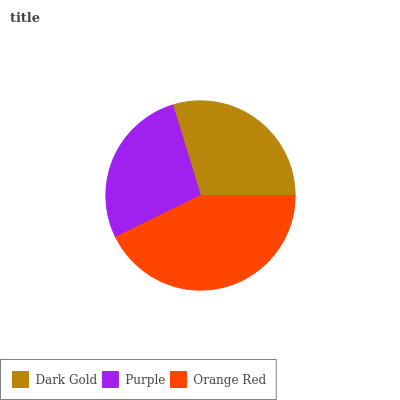Is Purple the minimum?
Answer yes or no. Yes. Is Orange Red the maximum?
Answer yes or no. Yes. Is Orange Red the minimum?
Answer yes or no. No. Is Purple the maximum?
Answer yes or no. No. Is Orange Red greater than Purple?
Answer yes or no. Yes. Is Purple less than Orange Red?
Answer yes or no. Yes. Is Purple greater than Orange Red?
Answer yes or no. No. Is Orange Red less than Purple?
Answer yes or no. No. Is Dark Gold the high median?
Answer yes or no. Yes. Is Dark Gold the low median?
Answer yes or no. Yes. Is Orange Red the high median?
Answer yes or no. No. Is Purple the low median?
Answer yes or no. No. 